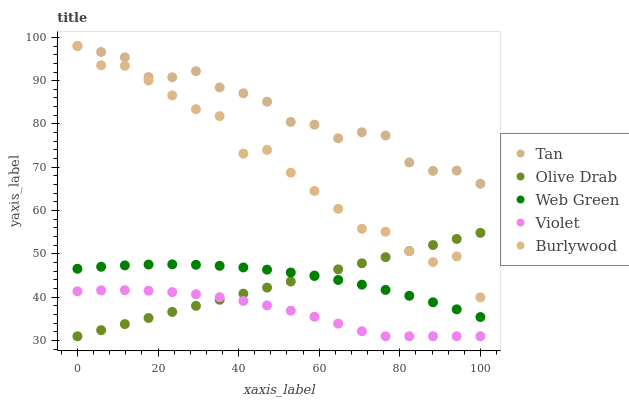Does Violet have the minimum area under the curve?
Answer yes or no. Yes. Does Tan have the maximum area under the curve?
Answer yes or no. Yes. Does Web Green have the minimum area under the curve?
Answer yes or no. No. Does Web Green have the maximum area under the curve?
Answer yes or no. No. Is Olive Drab the smoothest?
Answer yes or no. Yes. Is Burlywood the roughest?
Answer yes or no. Yes. Is Tan the smoothest?
Answer yes or no. No. Is Tan the roughest?
Answer yes or no. No. Does Olive Drab have the lowest value?
Answer yes or no. Yes. Does Web Green have the lowest value?
Answer yes or no. No. Does Tan have the highest value?
Answer yes or no. Yes. Does Web Green have the highest value?
Answer yes or no. No. Is Web Green less than Tan?
Answer yes or no. Yes. Is Tan greater than Olive Drab?
Answer yes or no. Yes. Does Olive Drab intersect Burlywood?
Answer yes or no. Yes. Is Olive Drab less than Burlywood?
Answer yes or no. No. Is Olive Drab greater than Burlywood?
Answer yes or no. No. Does Web Green intersect Tan?
Answer yes or no. No. 